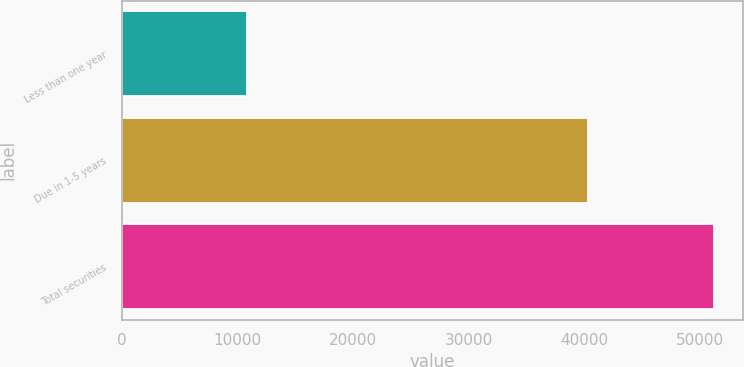<chart> <loc_0><loc_0><loc_500><loc_500><bar_chart><fcel>Less than one year<fcel>Due in 1-5 years<fcel>Total securities<nl><fcel>10870<fcel>40338<fcel>51208<nl></chart> 